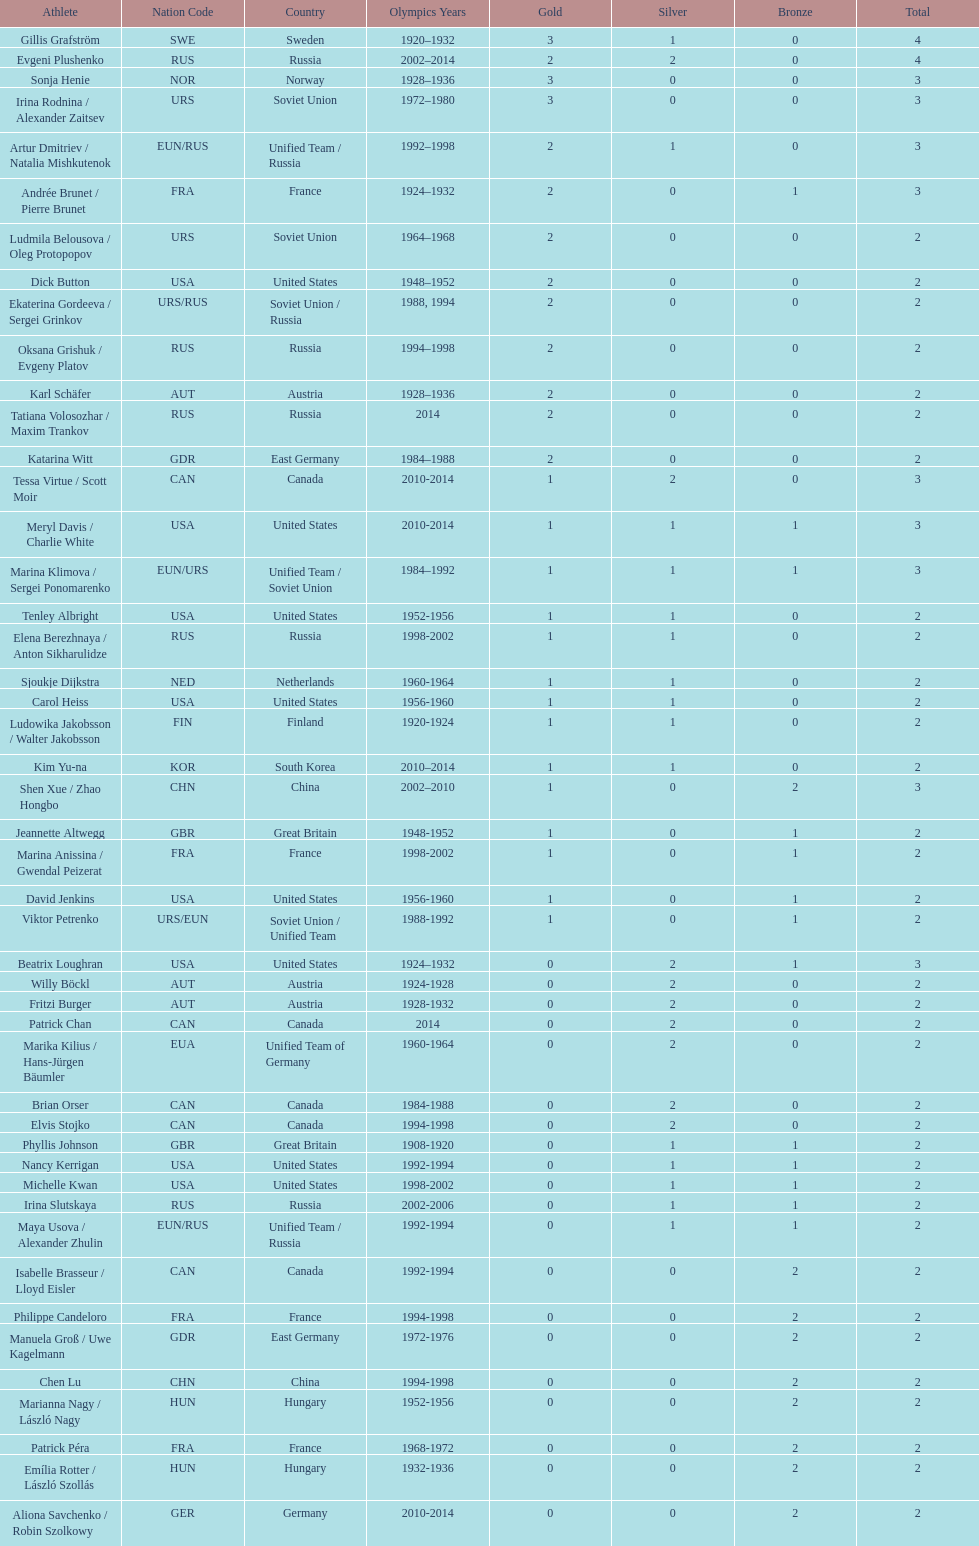How many more silver medals did gillis grafström have compared to sonja henie? 1. 